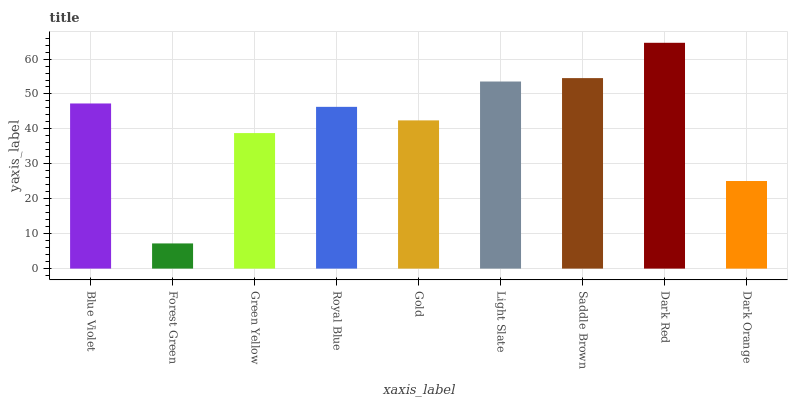Is Forest Green the minimum?
Answer yes or no. Yes. Is Dark Red the maximum?
Answer yes or no. Yes. Is Green Yellow the minimum?
Answer yes or no. No. Is Green Yellow the maximum?
Answer yes or no. No. Is Green Yellow greater than Forest Green?
Answer yes or no. Yes. Is Forest Green less than Green Yellow?
Answer yes or no. Yes. Is Forest Green greater than Green Yellow?
Answer yes or no. No. Is Green Yellow less than Forest Green?
Answer yes or no. No. Is Royal Blue the high median?
Answer yes or no. Yes. Is Royal Blue the low median?
Answer yes or no. Yes. Is Gold the high median?
Answer yes or no. No. Is Blue Violet the low median?
Answer yes or no. No. 